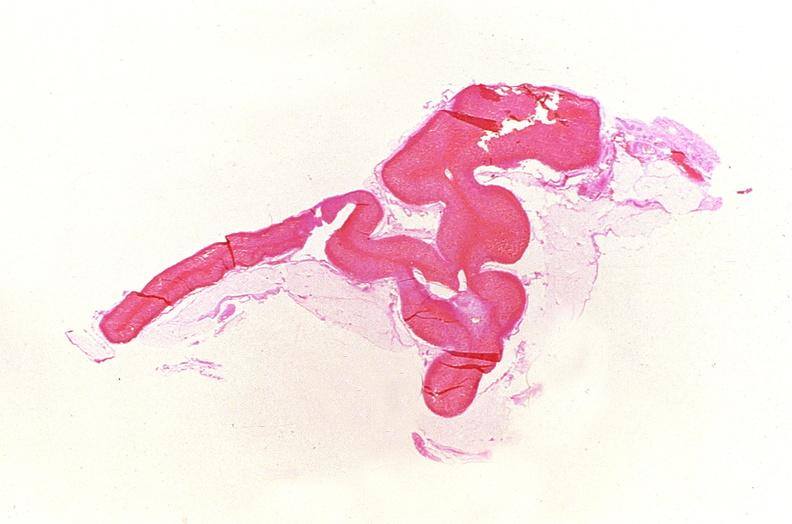does this image show adrenal gland, severe hemorrhage waterhouse-friderichsen syndrome?
Answer the question using a single word or phrase. Yes 